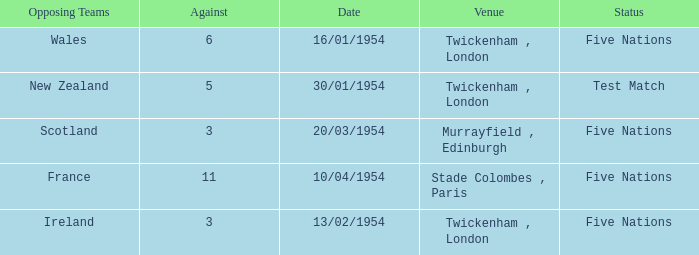What is the status when the against is 11? Five Nations. 